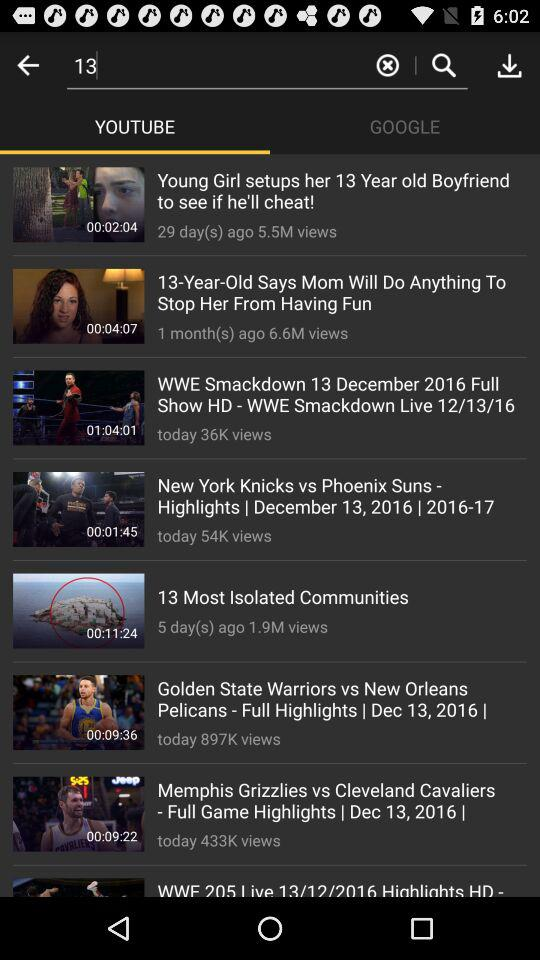Which video has 433K views? The video is "Memphis Grizzlies vs Cleveland Cavaliers - Full Game Highlights". 